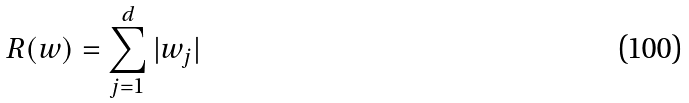Convert formula to latex. <formula><loc_0><loc_0><loc_500><loc_500>R ( w ) = \sum _ { j = 1 } ^ { d } | w _ { j } |</formula> 